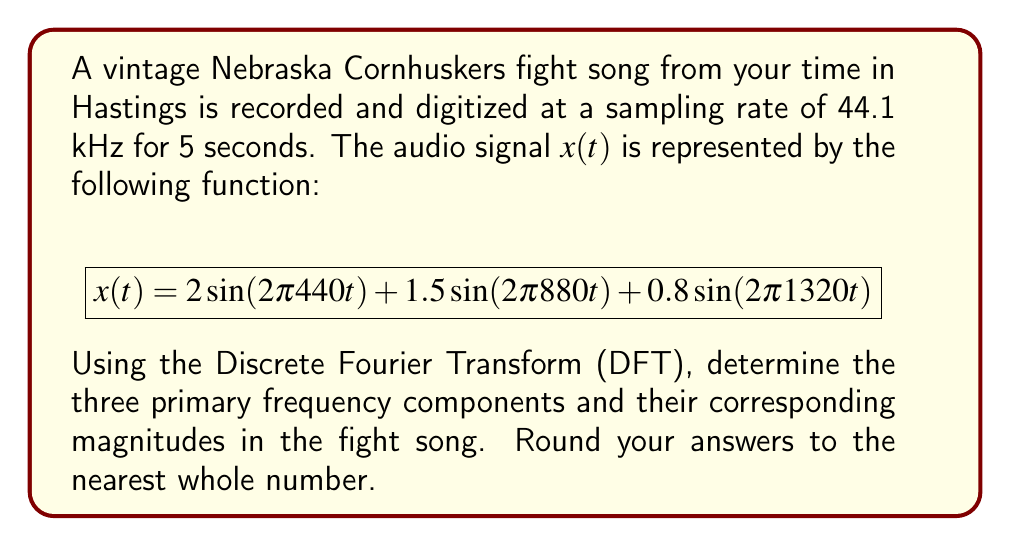What is the answer to this math problem? To solve this problem, we'll follow these steps:

1) First, we need to understand what the given function represents. The signal $x(t)$ is a sum of three sinusoidal components with different frequencies and amplitudes.

2) The general form of a sinusoidal component is $A\sin(2\pi ft)$, where $A$ is the amplitude and $f$ is the frequency in Hz.

3) Let's identify the frequencies and amplitudes for each component:

   Component 1: $A_1 = 2$, $f_1 = 440$ Hz
   Component 2: $A_2 = 1.5$, $f_2 = 880$ Hz
   Component 3: $A_3 = 0.8$, $f_3 = 1320$ Hz

4) In the frequency domain, each of these components will appear as a spike at its respective frequency, with a magnitude proportional to its amplitude.

5) The DFT will reveal these frequency components. The magnitude of each frequency component in the DFT is related to the amplitude of the sinusoid by a factor of N/2, where N is the number of samples.

6) Number of samples: N = sampling rate × duration = 44100 × 5 = 220500

7) To get the actual magnitude, we need to multiply each amplitude by N/2:

   Magnitude 1 = $2 \times (220500/2) = 220500$
   Magnitude 2 = $1.5 \times (220500/2) = 165375$
   Magnitude 3 = $0.8 \times (220500/2) = 88200$

8) Rounding to the nearest whole number:

   Frequency 1: 440 Hz, Magnitude: 220500
   Frequency 2: 880 Hz, Magnitude: 165375
   Frequency 3: 1320 Hz, Magnitude: 88200
Answer: The three primary frequency components and their corresponding magnitudes are:
440 Hz: 220500
880 Hz: 165375
1320 Hz: 88200 